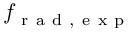Convert formula to latex. <formula><loc_0><loc_0><loc_500><loc_500>f _ { r a d , e x p }</formula> 